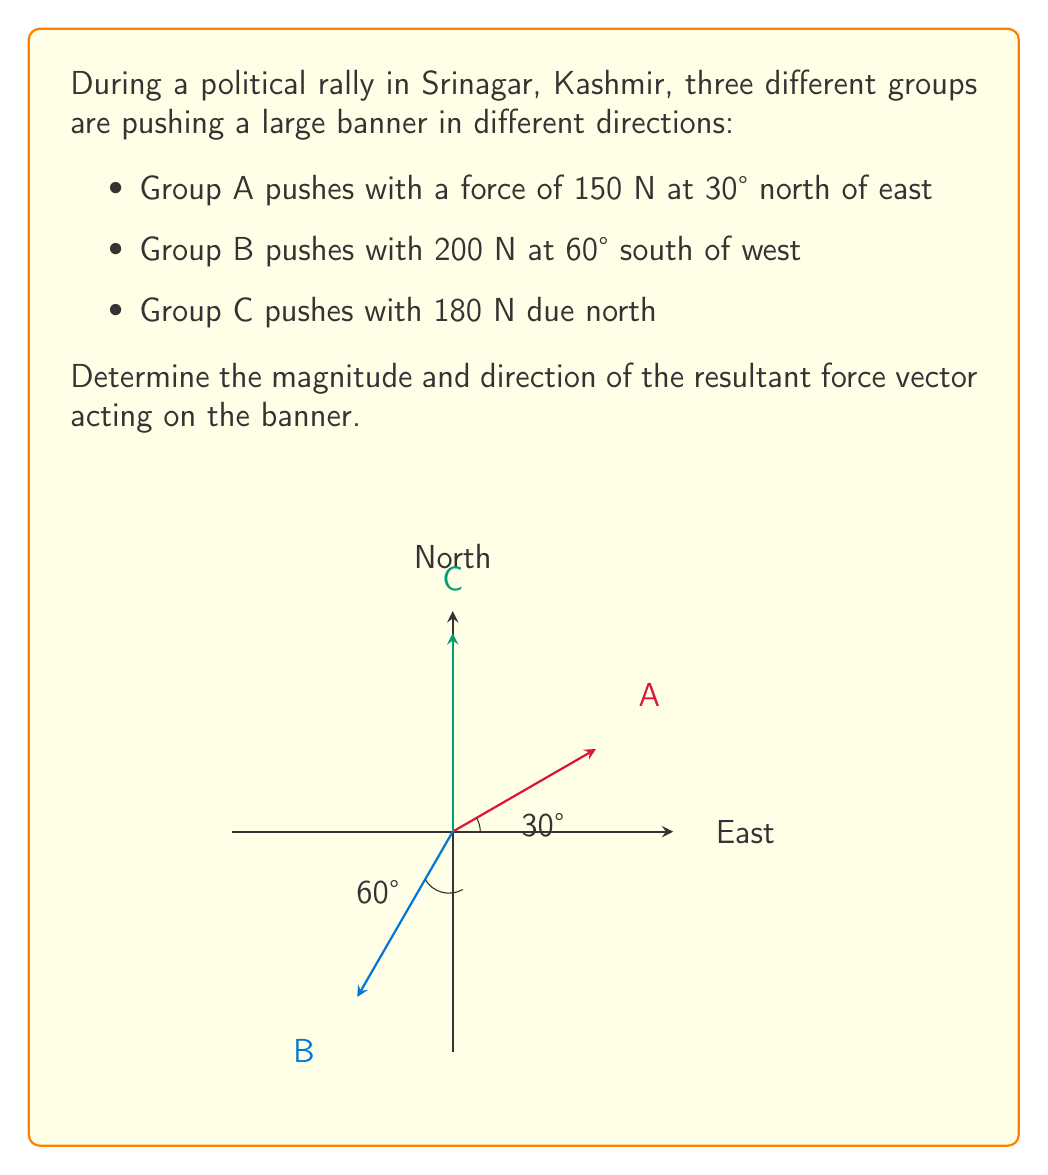Solve this math problem. Let's solve this problem step by step using vector addition:

1) First, let's break down each force vector into its x and y components:

   Group A: $F_A = 150$ N at 30° north of east
   $F_{Ax} = 150 \cos 30° = 150 \cdot \frac{\sqrt{3}}{2} = 129.90$ N
   $F_{Ay} = 150 \sin 30° = 150 \cdot \frac{1}{2} = 75$ N

   Group B: $F_B = 200$ N at 60° south of west
   $F_{Bx} = -200 \cos 30° = -200 \cdot \frac{\sqrt{3}}{2} = -173.21$ N
   $F_{By} = -200 \sin 30° = -200 \cdot \frac{1}{2} = -100$ N

   Group C: $F_C = 180$ N due north
   $F_{Cx} = 0$ N
   $F_{Cy} = 180$ N

2) Now, sum up all the x-components and y-components:

   $F_x = F_{Ax} + F_{Bx} + F_{Cx} = 129.90 - 173.21 + 0 = -43.31$ N
   $F_y = F_{Ay} + F_{By} + F_{Cy} = 75 - 100 + 180 = 155$ N

3) The resultant force vector $\vec{F}$ has components $(-43.31, 155)$.

4) To find the magnitude of the resultant force:

   $|\vec{F}| = \sqrt{F_x^2 + F_y^2} = \sqrt{(-43.31)^2 + 155^2} = 161.16$ N

5) To find the direction, we calculate the angle $\theta$ with respect to the positive x-axis:

   $\theta = \tan^{-1}(\frac{F_y}{F_x}) = \tan^{-1}(\frac{155}{-43.31}) = -74.37°$

   However, since $F_x$ is negative and $F_y$ is positive, we need to add 180° to this result:

   $\theta = -74.37° + 180° = 105.63°$

Therefore, the resultant force has a magnitude of 161.16 N and acts at an angle of 105.63° counterclockwise from the positive x-axis (east), or 15.63° north of west.
Answer: 161.16 N at 105.63° counterclockwise from east 